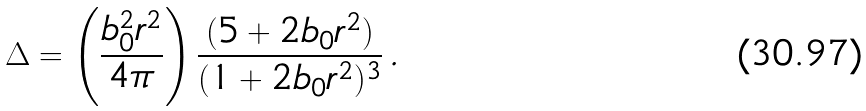<formula> <loc_0><loc_0><loc_500><loc_500>\Delta = \left ( \frac { b _ { 0 } ^ { 2 } r ^ { 2 } } { 4 \pi } \right ) \frac { ( 5 + 2 b _ { 0 } r ^ { 2 } ) } { ( 1 + 2 b _ { 0 } r ^ { 2 } ) ^ { 3 } } \, .</formula> 